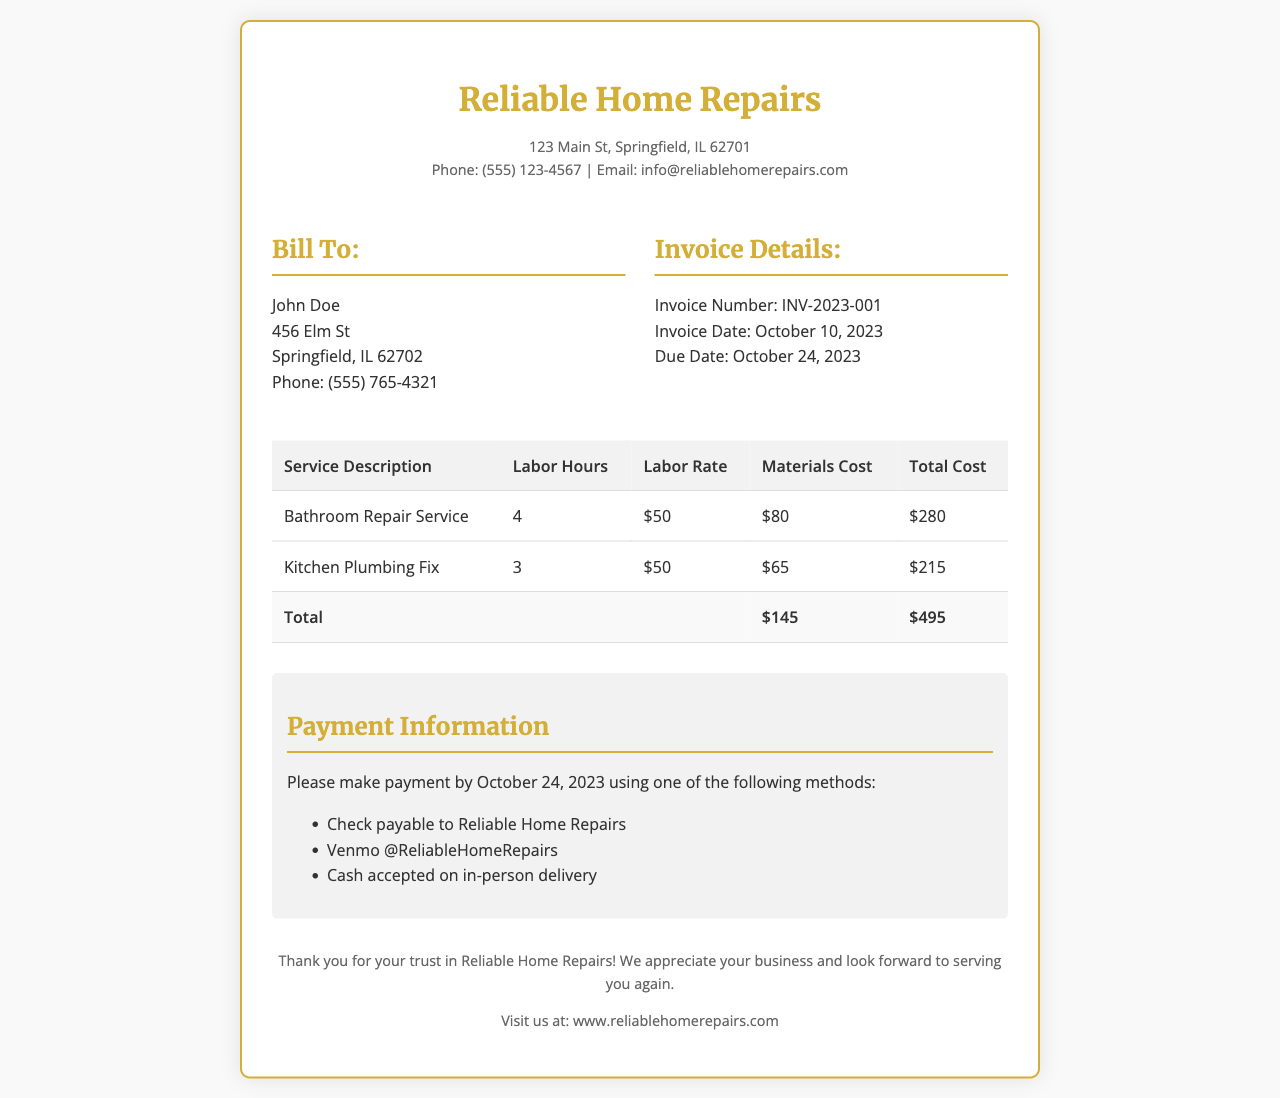What is the invoice number? The invoice number is mentioned in the invoice details section.
Answer: INV-2023-001 What is the total labor cost? The total labor cost can be derived by adding the labor costs from both services listed in the invoice.
Answer: $315 When is the due date for the payment? The due date for payment is specified under the invoice details section.
Answer: October 24, 2023 What services were provided? The services provided are detailed in the table under service description.
Answer: Bathroom Repair Service, Kitchen Plumbing Fix What is the total cost of materials used? The total materials cost is summed from the individual materials costs listed in the document.
Answer: $145 How many labor hours were billed for Kitchen Plumbing Fix? The number of labor hours for Kitchen Plumbing Fix is mentioned in the service description section.
Answer: 3 What payment methods are accepted? The payment information section lists the methods available for payment.
Answer: Check, Venmo, Cash What is the effective labor rate per hour? The labor rate per hour can be derived from the information in the table for both services.
Answer: $50 Which company issued the invoice? The issuing company is mentioned in the header of the invoice.
Answer: Reliable Home Repairs 